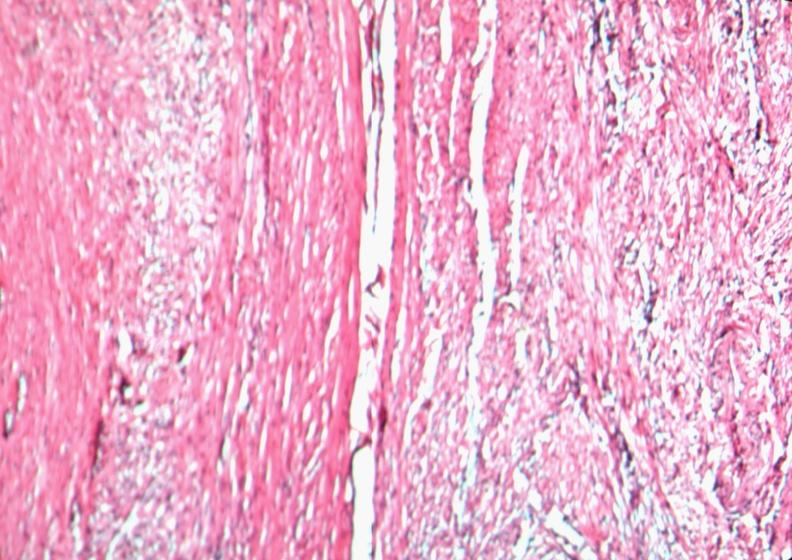s this image present?
Answer the question using a single word or phrase. No 